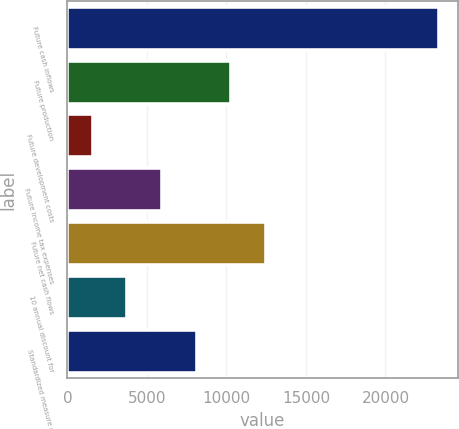<chart> <loc_0><loc_0><loc_500><loc_500><bar_chart><fcel>Future cash inflows<fcel>Future production<fcel>Future development costs<fcel>Future income tax expenses<fcel>Future net cash flows<fcel>10 annual discount for<fcel>Standardized measure of<nl><fcel>23385<fcel>10312.8<fcel>1598<fcel>5955.4<fcel>12491.5<fcel>3776.7<fcel>8134.1<nl></chart> 